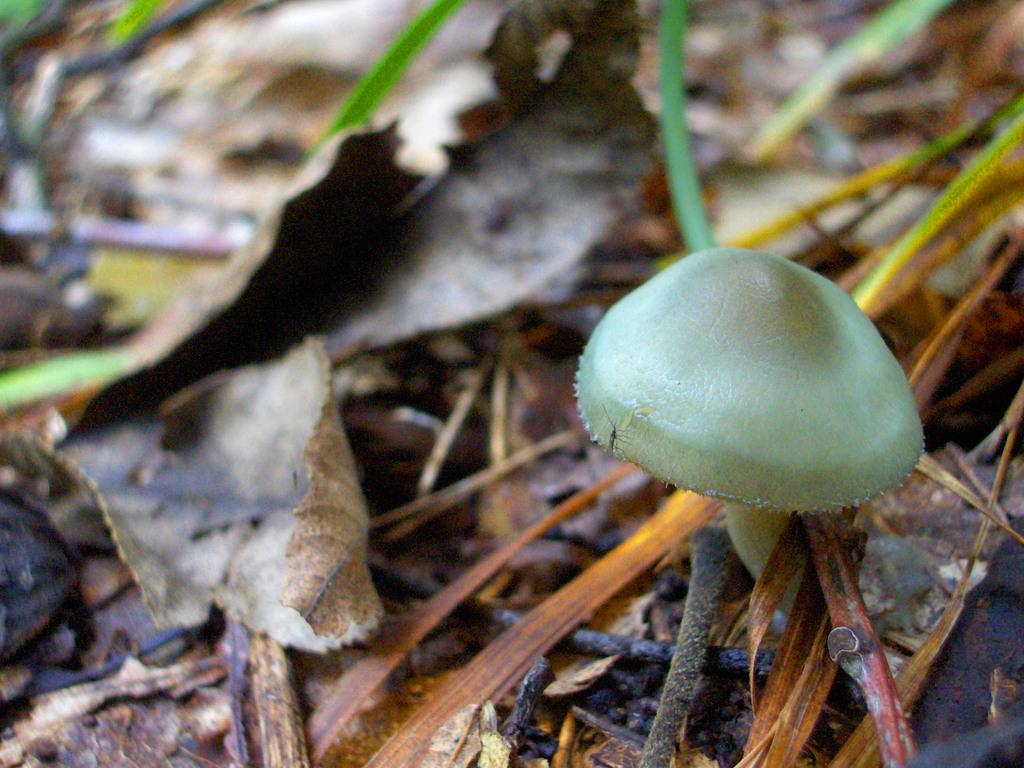What is the main subject of the image? There is a mushroom in the image. What can be seen in the background of the image? There are leaves in the background of the image. What type of match is being used to light the locket in the image? There is no match or locket present in the image; it only features a mushroom and leaves in the background. 